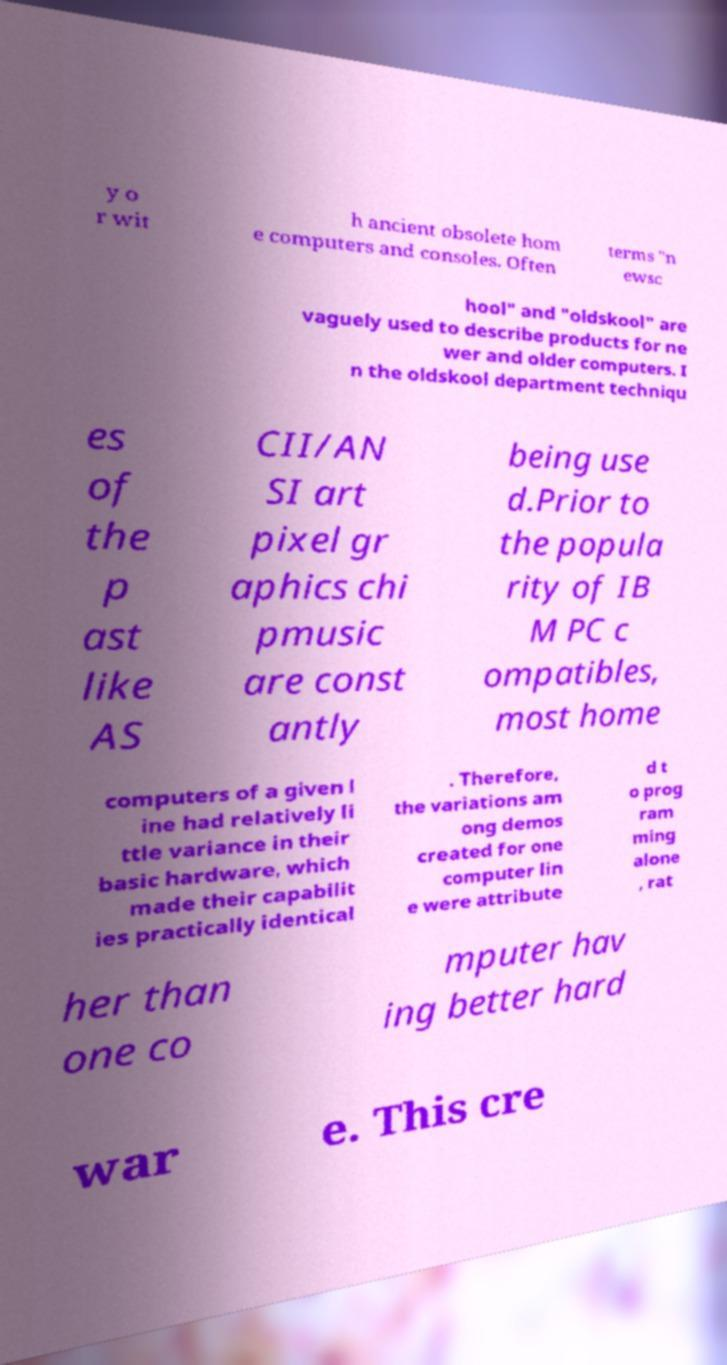What messages or text are displayed in this image? I need them in a readable, typed format. y o r wit h ancient obsolete hom e computers and consoles. Often terms "n ewsc hool" and "oldskool" are vaguely used to describe products for ne wer and older computers. I n the oldskool department techniqu es of the p ast like AS CII/AN SI art pixel gr aphics chi pmusic are const antly being use d.Prior to the popula rity of IB M PC c ompatibles, most home computers of a given l ine had relatively li ttle variance in their basic hardware, which made their capabilit ies practically identical . Therefore, the variations am ong demos created for one computer lin e were attribute d t o prog ram ming alone , rat her than one co mputer hav ing better hard war e. This cre 